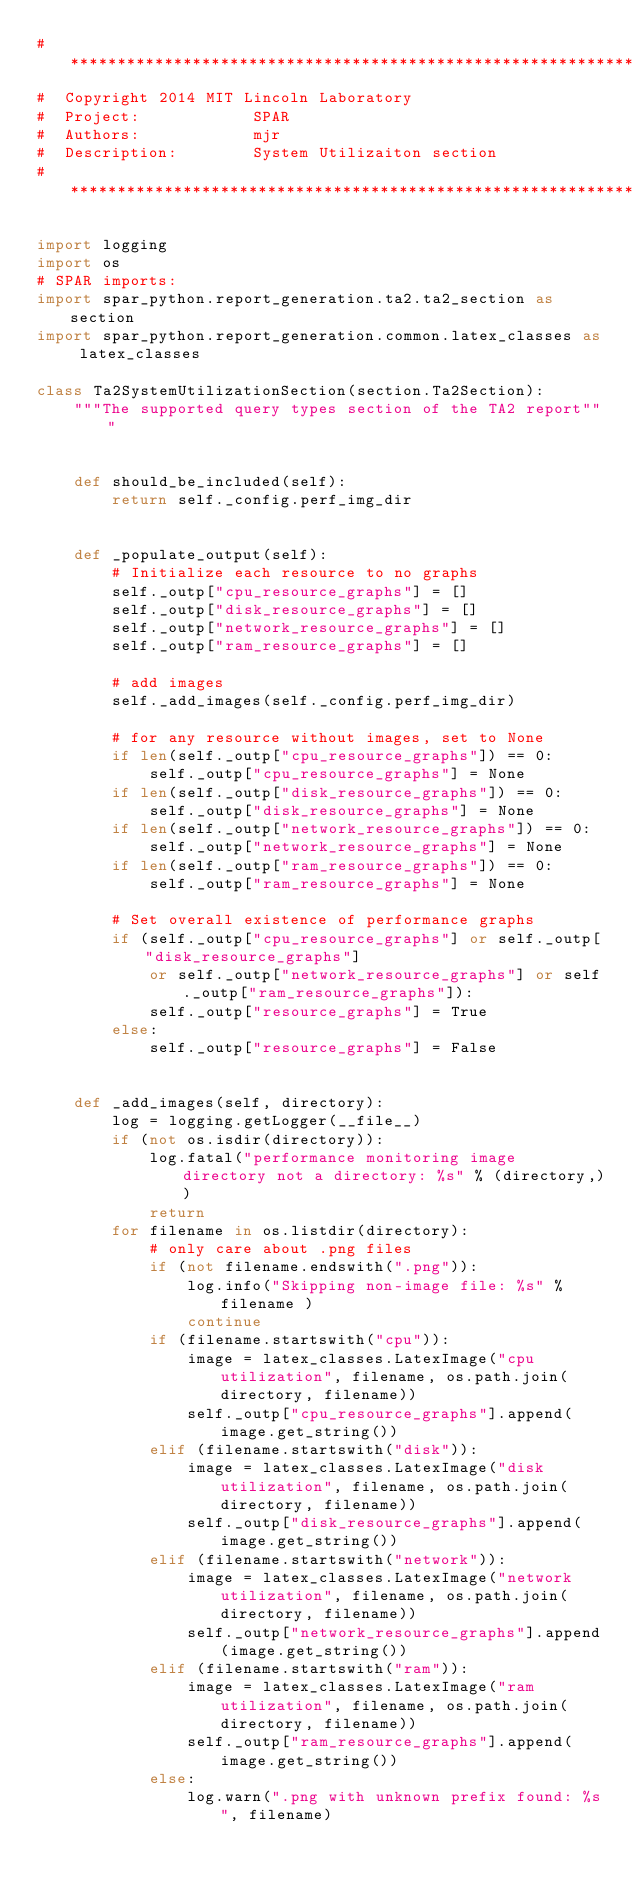Convert code to text. <code><loc_0><loc_0><loc_500><loc_500><_Python_># *****************************************************************
#  Copyright 2014 MIT Lincoln Laboratory  
#  Project:            SPAR
#  Authors:            mjr
#  Description:        System Utilizaiton section
# *****************************************************************

import logging
import os
# SPAR imports:
import spar_python.report_generation.ta2.ta2_section as section
import spar_python.report_generation.common.latex_classes as latex_classes

class Ta2SystemUtilizationSection(section.Ta2Section):
    """The supported query types section of the TA2 report"""
    
    
    def should_be_included(self):
        return self._config.perf_img_dir
    
    
    def _populate_output(self):
        # Initialize each resource to no graphs
        self._outp["cpu_resource_graphs"] = []
        self._outp["disk_resource_graphs"] = []
        self._outp["network_resource_graphs"] = []
        self._outp["ram_resource_graphs"] = []
        
        # add images
        self._add_images(self._config.perf_img_dir)
        
        # for any resource without images, set to None
        if len(self._outp["cpu_resource_graphs"]) == 0:
            self._outp["cpu_resource_graphs"] = None
        if len(self._outp["disk_resource_graphs"]) == 0:
            self._outp["disk_resource_graphs"] = None
        if len(self._outp["network_resource_graphs"]) == 0:
            self._outp["network_resource_graphs"] = None
        if len(self._outp["ram_resource_graphs"]) == 0:
            self._outp["ram_resource_graphs"] = None
        
        # Set overall existence of performance graphs
        if (self._outp["cpu_resource_graphs"] or self._outp["disk_resource_graphs"]
            or self._outp["network_resource_graphs"] or self._outp["ram_resource_graphs"]):
            self._outp["resource_graphs"] = True
        else:
            self._outp["resource_graphs"] = False
        
        
    def _add_images(self, directory):
        log = logging.getLogger(__file__)
        if (not os.isdir(directory)):
            log.fatal("performance monitoring image directory not a directory: %s" % (directory,))
            return
        for filename in os.listdir(directory):
            # only care about .png files
            if (not filename.endswith(".png")):
                log.info("Skipping non-image file: %s" % filename )
                continue
            if (filename.startswith("cpu")):
                image = latex_classes.LatexImage("cpu utilization", filename, os.path.join(directory, filename))
                self._outp["cpu_resource_graphs"].append(image.get_string())
            elif (filename.startswith("disk")):
                image = latex_classes.LatexImage("disk utilization", filename, os.path.join(directory, filename))
                self._outp["disk_resource_graphs"].append(image.get_string())
            elif (filename.startswith("network")):
                image = latex_classes.LatexImage("network utilization", filename, os.path.join(directory, filename))
                self._outp["network_resource_graphs"].append(image.get_string())
            elif (filename.startswith("ram")):
                image = latex_classes.LatexImage("ram utilization", filename, os.path.join(directory, filename))
                self._outp["ram_resource_graphs"].append(image.get_string())
            else:
                log.warn(".png with unknown prefix found: %s", filename)
        
            
            
        
            
</code> 